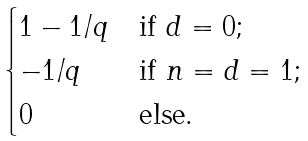Convert formula to latex. <formula><loc_0><loc_0><loc_500><loc_500>\begin{cases} 1 - 1 / q & \text {if $d=0$;} \\ - 1 / q & \text {if $n=d=1$;} \\ 0 & \text {else.} \end{cases}</formula> 